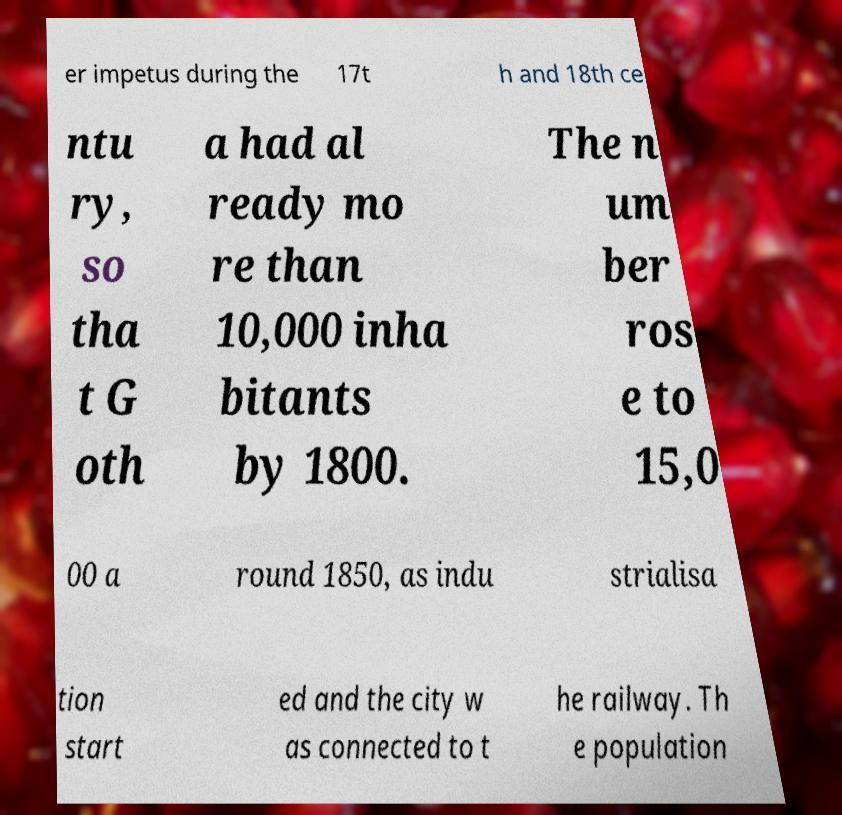I need the written content from this picture converted into text. Can you do that? er impetus during the 17t h and 18th ce ntu ry, so tha t G oth a had al ready mo re than 10,000 inha bitants by 1800. The n um ber ros e to 15,0 00 a round 1850, as indu strialisa tion start ed and the city w as connected to t he railway. Th e population 